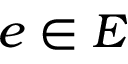Convert formula to latex. <formula><loc_0><loc_0><loc_500><loc_500>e \in E</formula> 